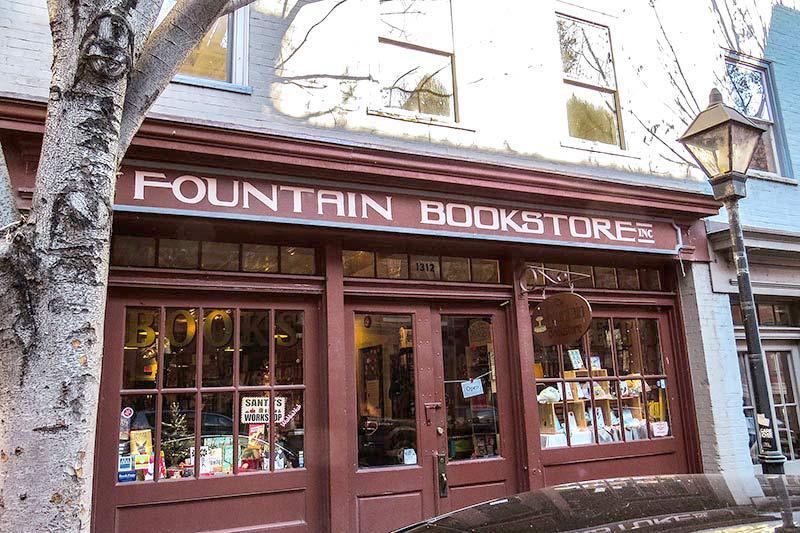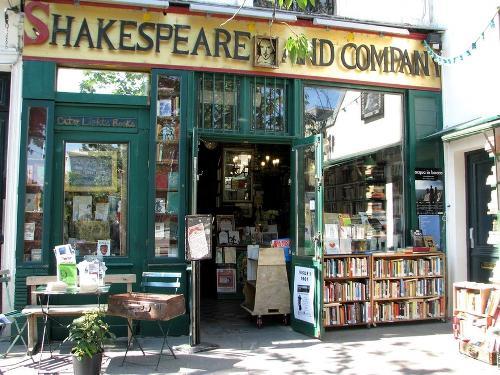The first image is the image on the left, the second image is the image on the right. Examine the images to the left and right. Is the description "An image shows at least two people walking past a shop." accurate? Answer yes or no. No. 